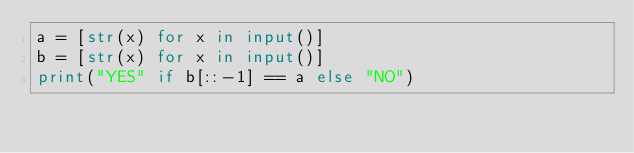Convert code to text. <code><loc_0><loc_0><loc_500><loc_500><_Python_>a = [str(x) for x in input()]
b = [str(x) for x in input()]
print("YES" if b[::-1] == a else "NO")</code> 